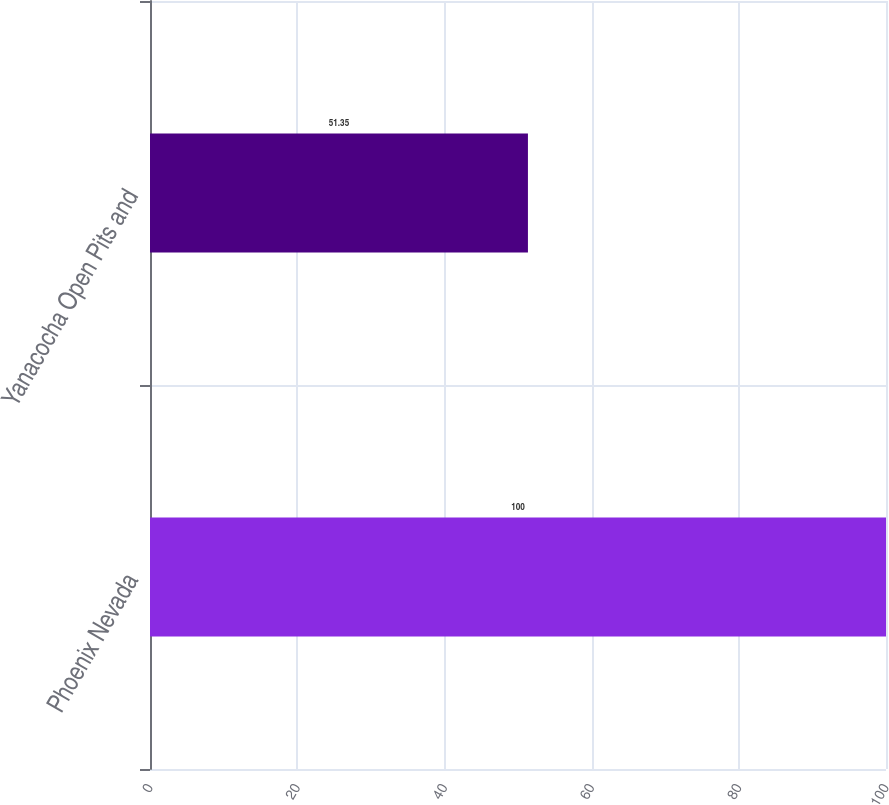Convert chart to OTSL. <chart><loc_0><loc_0><loc_500><loc_500><bar_chart><fcel>Phoenix Nevada<fcel>Yanacocha Open Pits and<nl><fcel>100<fcel>51.35<nl></chart> 